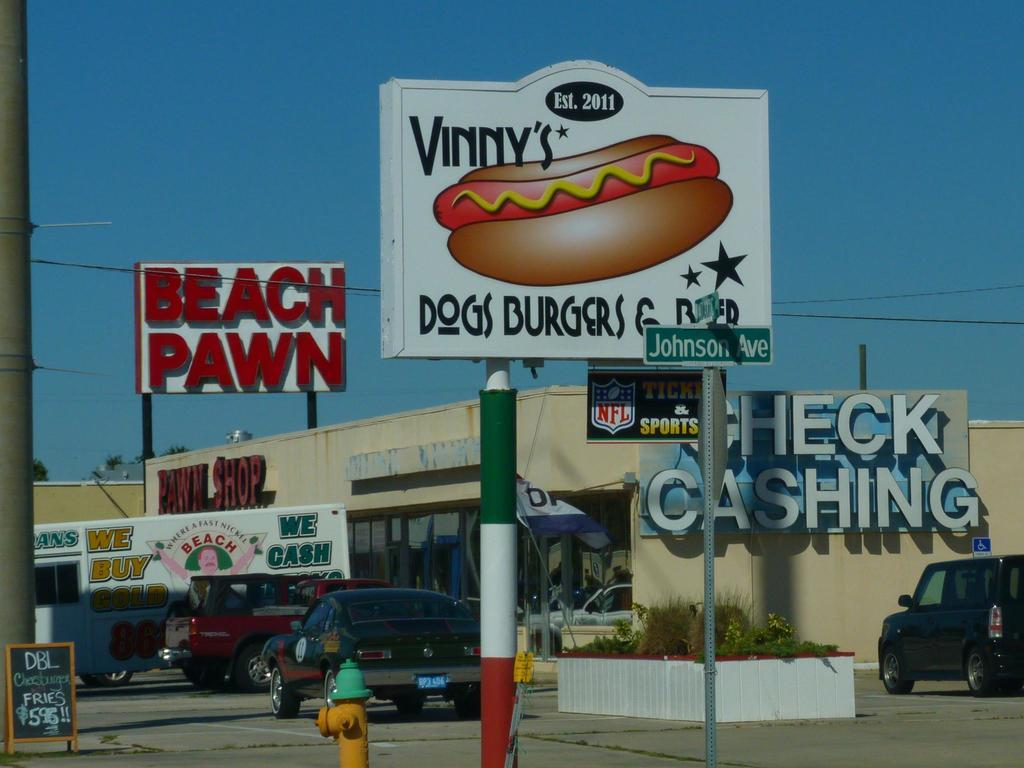<image>
Give a short and clear explanation of the subsequent image. a sign that has dogs burgers on it 